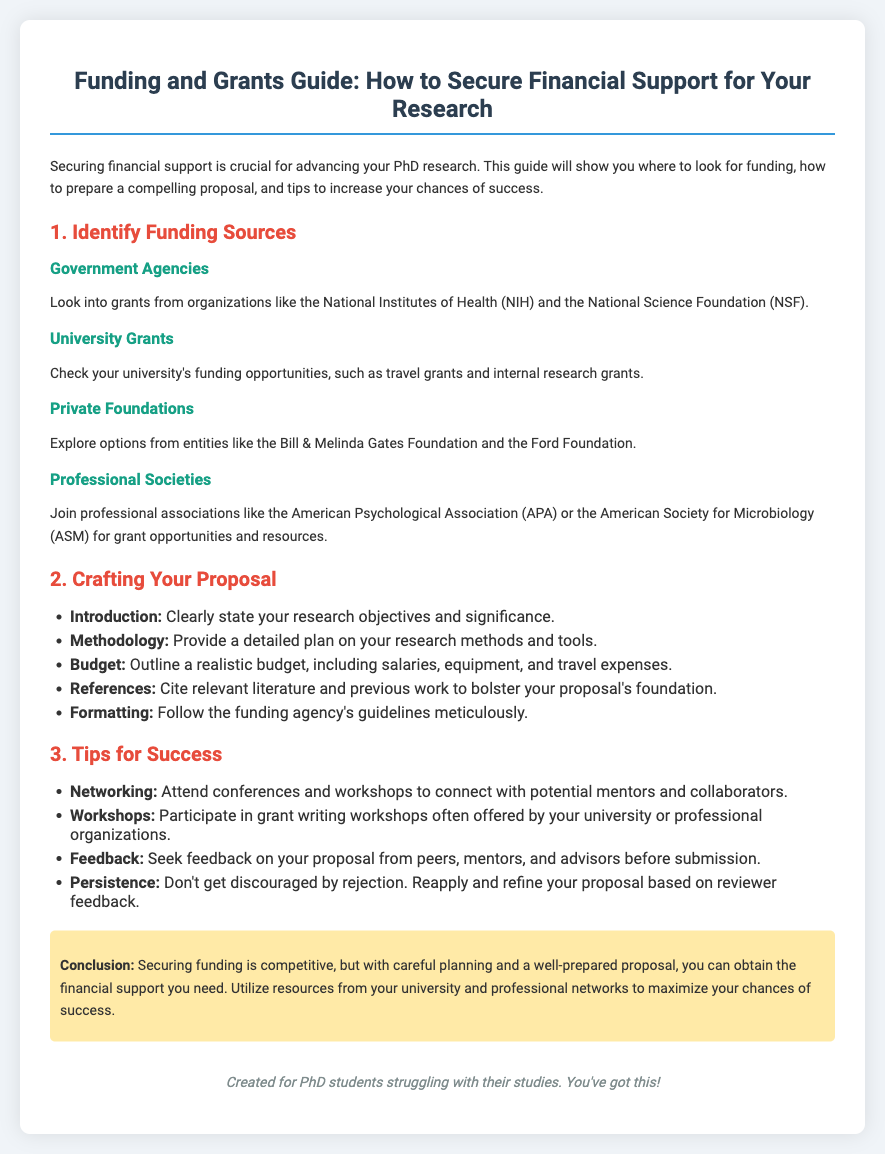What is the primary purpose of the guide? The guide aims to provide advice on securing financial support for PhD research.
Answer: To secure financial support for your research Which organization is mentioned as a funding source in the government agencies section? The National Institutes of Health (NIH) is one of the government funding sources listed.
Answer: National Institutes of Health (NIH) What is the first step outlined in the guide for securing funding? The first step mentioned is to identify funding sources.
Answer: Identify Funding Sources Name one type of grant you can find at your university. The document mentions travel grants as an example of university grants available.
Answer: Travel grants What is one essential component of a research proposal? The methodology is outlined as a crucial section of the research proposal to be detailed.
Answer: Methodology What should you seek from peers and mentors regarding your proposal? The guide emphasizes the importance of obtaining feedback on your proposal before submission.
Answer: Feedback Which association is recommended for grant opportunities? The American Psychological Association (APA) is a professional society suggested for grant opportunities.
Answer: American Psychological Association (APA) What attitude should you maintain after receiving a rejection? It encourages persistence, suggesting that you should reapply and refine your proposal based on feedback.
Answer: Persistence 